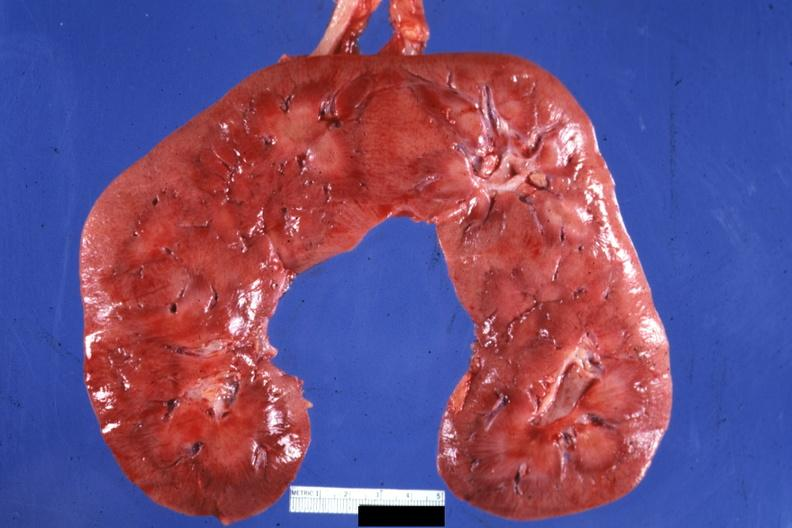what is present?
Answer the question using a single word or phrase. Horseshoe kidney 